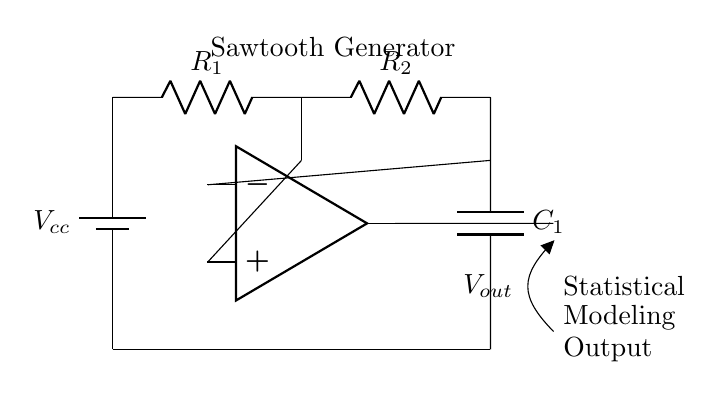What is the output waveform type of this circuit? The circuit is designed as a relaxation oscillator to generate a sawtooth waveform, as indicated by its components and configuration.
Answer: Sawtooth What components are involved in the feedback loop? The feedback loop typically includes the operational amplifier, resistors, and capacitors, creating a path for the signal to stabilize and oscillate.
Answer: Operational amplifier, resistors, capacitors What is the purpose of the capacitor in this circuit? The capacitor's role is to store and release charge, which contributes to the timing and shape of the sawtooth waveform generated by the oscillator.
Answer: Timing What is the function of the operational amplifier? The operational amplifier amplifies the difference in voltage between its two input terminals, enabling the feedback necessary for oscillation and waveform generation.
Answer: Amplification How many resistors are present in the circuit? There are two resistors shown in the circuit that help to set the gain and timing characteristics of the oscillator.
Answer: Two What does the voltage labeled as Vcc represent? Vcc represents the positive supply voltage required to power the circuit, providing the necessary voltage for the components to operate.
Answer: Positive supply voltage What does the output label signify in this circuit? The output label indicates the point where the generated sawtooth waveform is outputted, which can be used in statistical modeling or further processing.
Answer: Sawtooth waveform output 